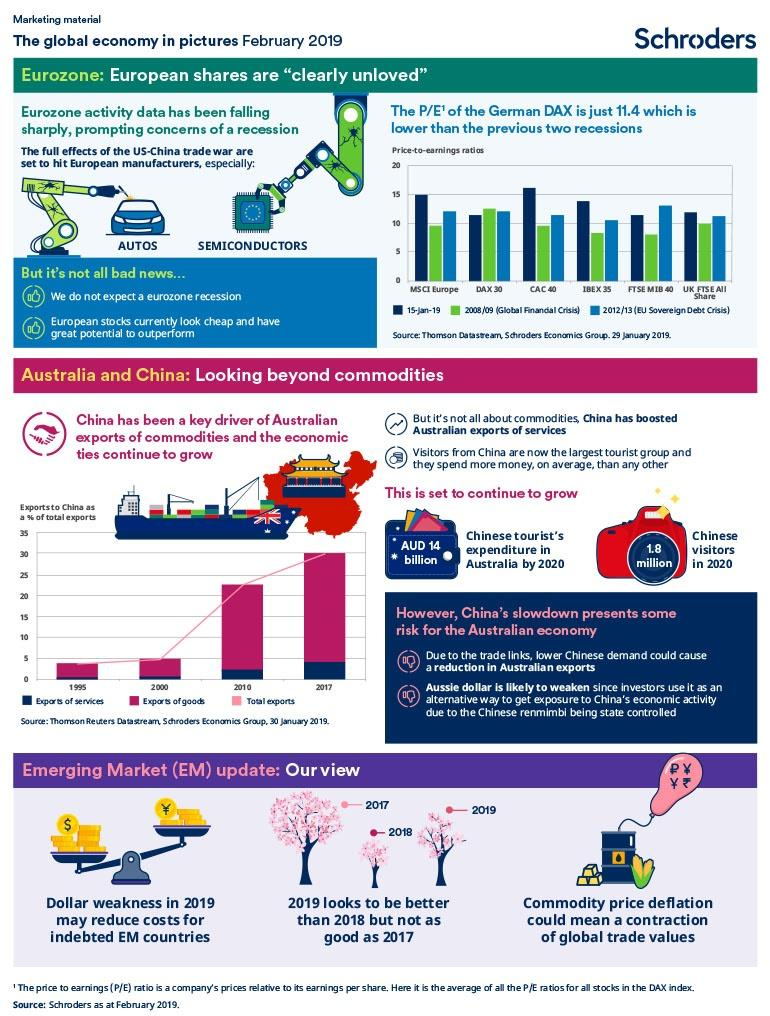Indicate a few pertinent items in this graphic. According to the graph, the percentage of exports of goods during 2000 was approximately 5%. According to the data, in 2017, the percentage of exports of services reached a high level. According to the graph, total exports reached 30% in 2017. The US-China trade issues have had a significant impact on several industries, including the automotive and semiconductor sectors. P/E stands for Price-to-Earnings, which is a financial ratio that compares a company's current stock price to its earnings per share. 